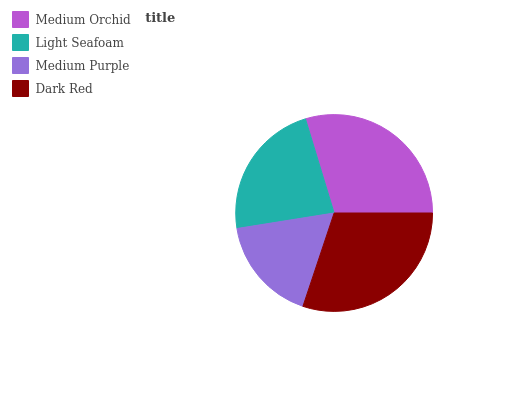Is Medium Purple the minimum?
Answer yes or no. Yes. Is Dark Red the maximum?
Answer yes or no. Yes. Is Light Seafoam the minimum?
Answer yes or no. No. Is Light Seafoam the maximum?
Answer yes or no. No. Is Medium Orchid greater than Light Seafoam?
Answer yes or no. Yes. Is Light Seafoam less than Medium Orchid?
Answer yes or no. Yes. Is Light Seafoam greater than Medium Orchid?
Answer yes or no. No. Is Medium Orchid less than Light Seafoam?
Answer yes or no. No. Is Medium Orchid the high median?
Answer yes or no. Yes. Is Light Seafoam the low median?
Answer yes or no. Yes. Is Medium Purple the high median?
Answer yes or no. No. Is Medium Purple the low median?
Answer yes or no. No. 